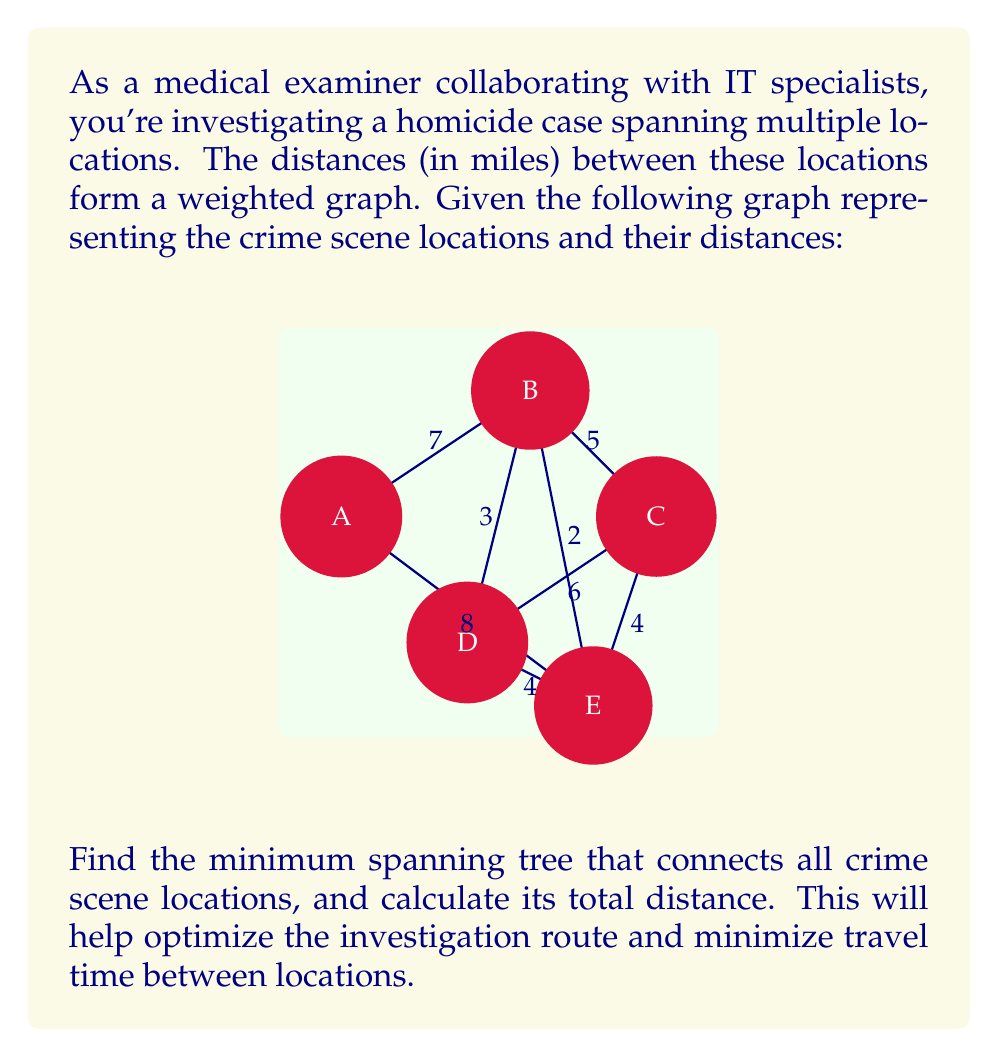Could you help me with this problem? To find the minimum spanning tree, we'll use Kruskal's algorithm:

1) First, list all edges and their weights in ascending order:
   B-E: 2
   B-D: 3
   D-E: 4
   C-E: 4
   B-C: 5
   C-D: 6
   A-B: 7
   A-E: 8

2) Start with an empty graph and add edges in this order, skipping any that would create a cycle:

   - Add B-E (2)
   - Add B-D (3)
   - Add D-E (4) - skip, would create cycle
   - Add C-E (4)
   - Add B-C (5) - skip, would create cycle
   - Add C-D (6) - skip, would create cycle
   - Add A-B (7)

3) The minimum spanning tree is now complete, as it connects all 5 vertices with 4 edges.

4) Calculate the total distance:
   $$\text{Total Distance} = 2 + 3 + 4 + 7 = 16\text{ miles}$$

The minimum spanning tree consists of edges B-E, B-D, C-E, and A-B, with a total distance of 16 miles.
Answer: 16 miles 